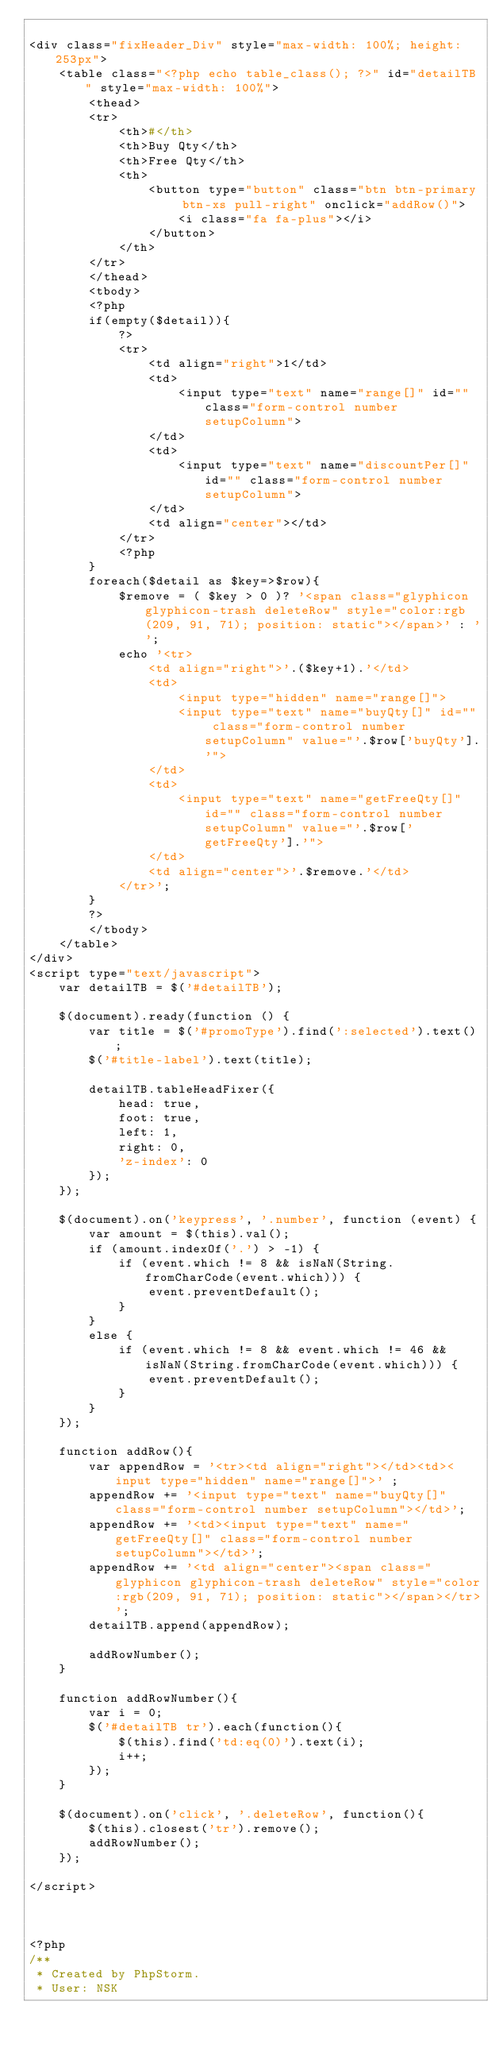<code> <loc_0><loc_0><loc_500><loc_500><_PHP_>
<div class="fixHeader_Div" style="max-width: 100%; height: 253px">
    <table class="<?php echo table_class(); ?>" id="detailTB" style="max-width: 100%">
        <thead>
        <tr>
            <th>#</th>
            <th>Buy Qty</th>
            <th>Free Qty</th>
            <th>
                <button type="button" class="btn btn-primary btn-xs pull-right" onclick="addRow()">
                    <i class="fa fa-plus"></i>
                </button>
            </th>
        </tr>
        </thead>
        <tbody>
        <?php
        if(empty($detail)){
            ?>
            <tr>
                <td align="right">1</td>
                <td>
                    <input type="text" name="range[]" id="" class="form-control number setupColumn">
                </td>
                <td>
                    <input type="text" name="discountPer[]" id="" class="form-control number setupColumn">
                </td>
                <td align="center"></td>
            </tr>
            <?php
        }
        foreach($detail as $key=>$row){
            $remove = ( $key > 0 )? '<span class="glyphicon glyphicon-trash deleteRow" style="color:rgb(209, 91, 71); position: static"></span>' : '';
            echo '<tr>
                <td align="right">'.($key+1).'</td>
                <td>
                    <input type="hidden" name="range[]">
                    <input type="text" name="buyQty[]" id="" class="form-control number setupColumn" value="'.$row['buyQty'].'">
                </td>
                <td>
                    <input type="text" name="getFreeQty[]" id="" class="form-control number setupColumn" value="'.$row['getFreeQty'].'">
                </td>
                <td align="center">'.$remove.'</td>
            </tr>';
        }
        ?>
        </tbody>
    </table>
</div>
<script type="text/javascript">
    var detailTB = $('#detailTB');

    $(document).ready(function () {
        var title = $('#promoType').find(':selected').text();
        $('#title-label').text(title);

        detailTB.tableHeadFixer({
            head: true,
            foot: true,
            left: 1,
            right: 0,
            'z-index': 0
        });
    });

    $(document).on('keypress', '.number', function (event) {
        var amount = $(this).val();
        if (amount.indexOf('.') > -1) {
            if (event.which != 8 && isNaN(String.fromCharCode(event.which))) {
                event.preventDefault();
            }
        }
        else {
            if (event.which != 8 && event.which != 46 && isNaN(String.fromCharCode(event.which))) {
                event.preventDefault();
            }
        }
    });

    function addRow(){
        var appendRow = '<tr><td align="right"></td><td><input type="hidden" name="range[]">' ;
        appendRow += '<input type="text" name="buyQty[]" class="form-control number setupColumn"></td>';
        appendRow += '<td><input type="text" name="getFreeQty[]" class="form-control number setupColumn"></td>';
        appendRow += '<td align="center"><span class="glyphicon glyphicon-trash deleteRow" style="color:rgb(209, 91, 71); position: static"></span></tr>';
        detailTB.append(appendRow);

        addRowNumber();
    }

    function addRowNumber(){
        var i = 0;
        $('#detailTB tr').each(function(){
            $(this).find('td:eq(0)').text(i);
            i++;
        });
    }

    $(document).on('click', '.deleteRow', function(){
        $(this).closest('tr').remove();
        addRowNumber();
    });

</script>



<?php
/**
 * Created by PhpStorm.
 * User: NSK</code> 